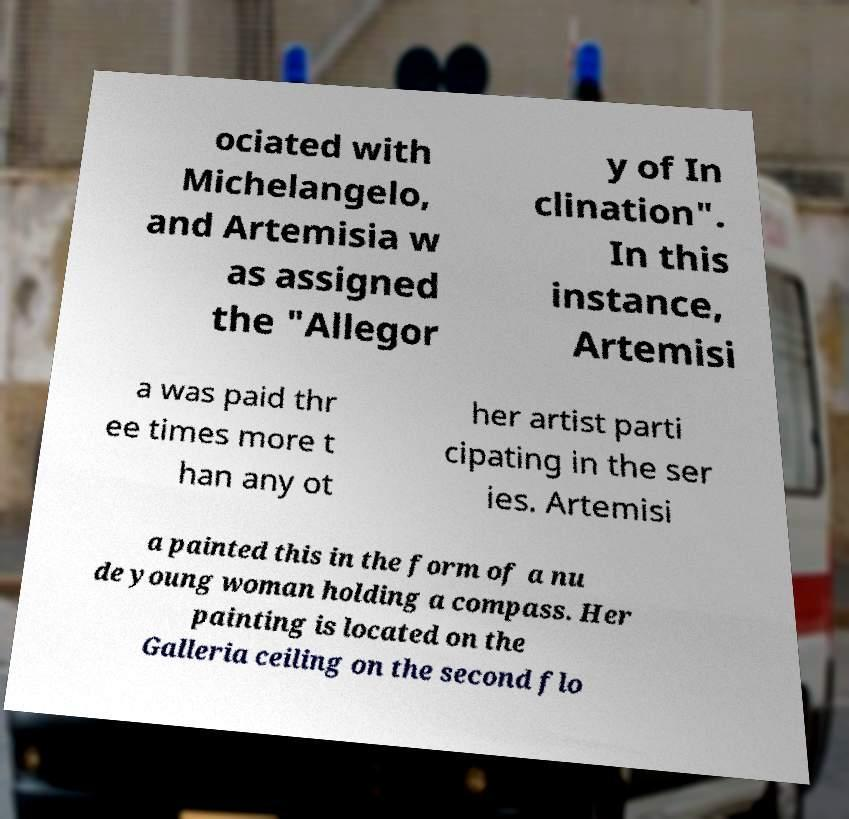For documentation purposes, I need the text within this image transcribed. Could you provide that? ociated with Michelangelo, and Artemisia w as assigned the "Allegor y of In clination". In this instance, Artemisi a was paid thr ee times more t han any ot her artist parti cipating in the ser ies. Artemisi a painted this in the form of a nu de young woman holding a compass. Her painting is located on the Galleria ceiling on the second flo 